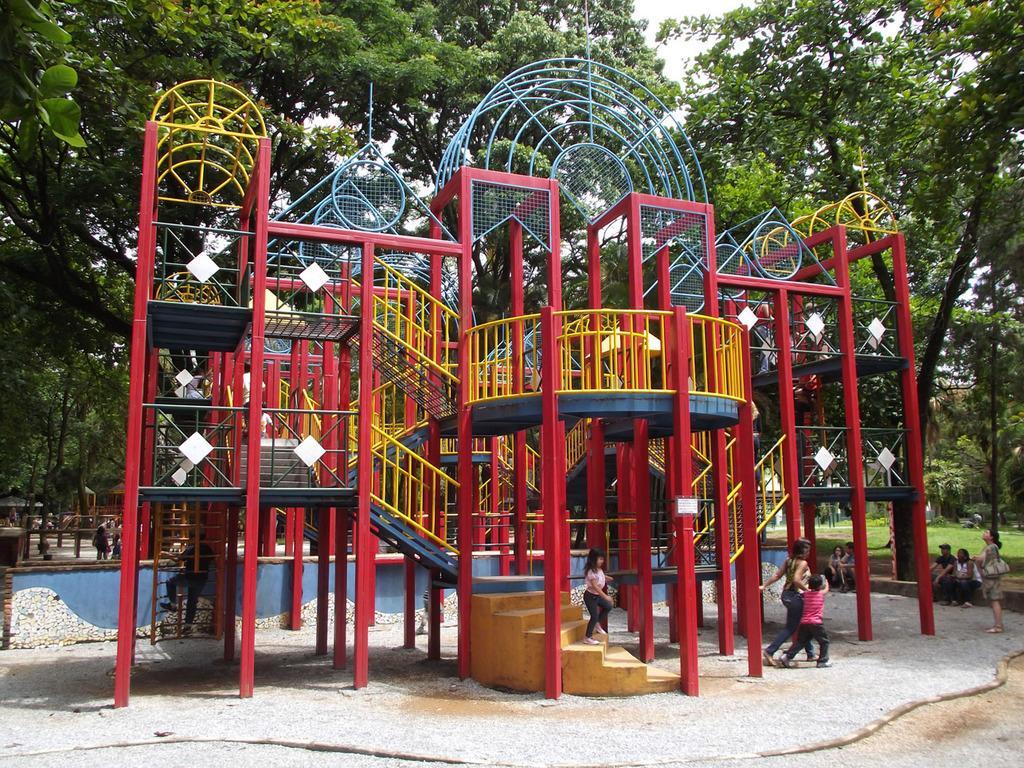Can you describe this image briefly? In this image we can see a playground and there are people. In the background there are trees. We can see stairs. There is sky. 